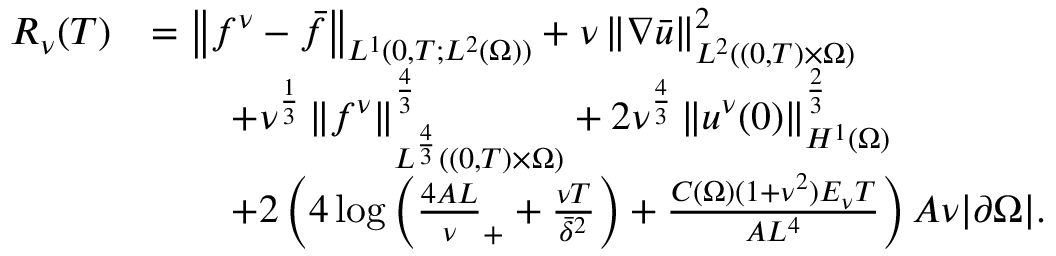<formula> <loc_0><loc_0><loc_500><loc_500>\begin{array} { r l } { R _ { \nu } ( T ) } & { = \left \| f ^ { \nu } - \bar { f } \right \| _ { L ^ { 1 } ( 0 , T ; L ^ { 2 } ( \Omega ) ) } + \nu \left \| \nabla \bar { u } \right \| _ { L ^ { 2 } ( ( 0 , T ) \times \Omega ) } ^ { 2 } } \\ & { \quad + \nu ^ { \frac { 1 } { 3 } } \left \| f ^ { \nu } \right \| _ { L ^ { \frac { 4 } { 3 } } ( ( 0 , T ) \times \Omega ) } ^ { \frac { 4 } { 3 } } + 2 \nu ^ { \frac { 4 } { 3 } } \left \| u ^ { \nu } ( 0 ) \right \| _ { H ^ { 1 } ( \Omega ) } ^ { \frac { 2 } { 3 } } } \\ & { \quad + 2 \left ( 4 \log \left ( \frac { 4 A L } \nu _ { + } + \frac { \nu T } { \bar { \delta } ^ { 2 } } \right ) + \frac { C ( \Omega ) ( 1 + \nu ^ { 2 } ) E _ { \nu } T } { A L ^ { 4 } } \right ) A \nu | \partial \Omega | . } \end{array}</formula> 